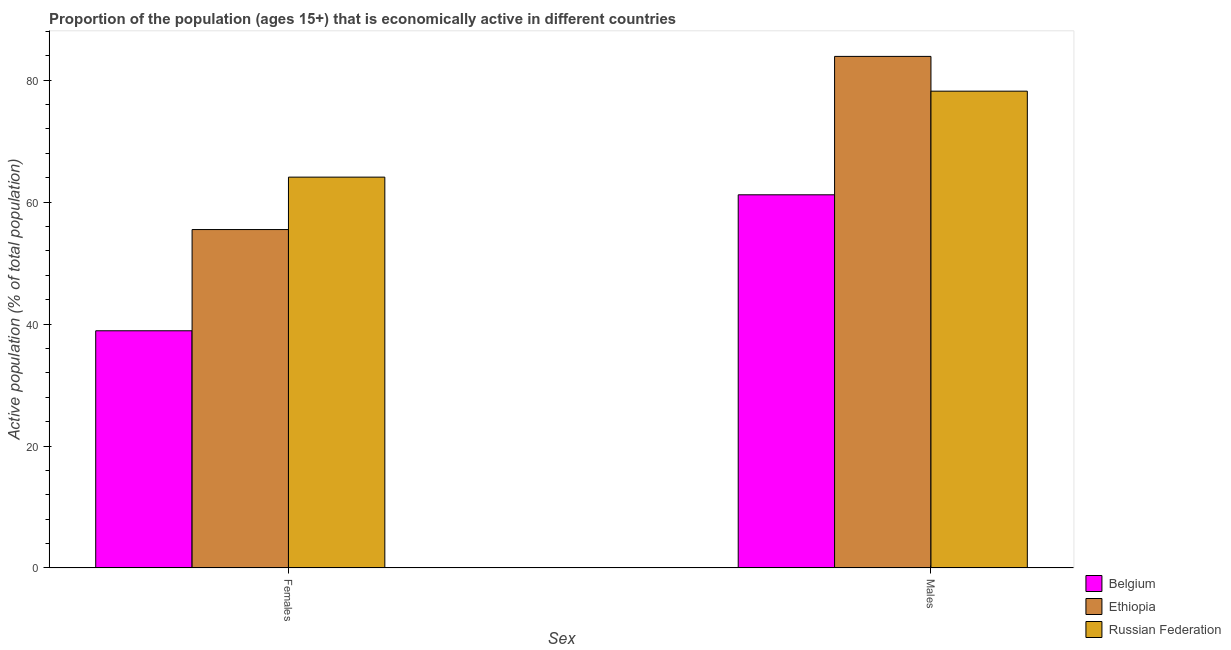How many different coloured bars are there?
Keep it short and to the point. 3. How many groups of bars are there?
Keep it short and to the point. 2. Are the number of bars on each tick of the X-axis equal?
Offer a terse response. Yes. How many bars are there on the 2nd tick from the left?
Offer a terse response. 3. How many bars are there on the 1st tick from the right?
Give a very brief answer. 3. What is the label of the 2nd group of bars from the left?
Keep it short and to the point. Males. What is the percentage of economically active female population in Ethiopia?
Your response must be concise. 55.5. Across all countries, what is the maximum percentage of economically active male population?
Offer a very short reply. 83.9. Across all countries, what is the minimum percentage of economically active female population?
Offer a terse response. 38.9. In which country was the percentage of economically active male population maximum?
Your answer should be compact. Ethiopia. In which country was the percentage of economically active male population minimum?
Offer a terse response. Belgium. What is the total percentage of economically active female population in the graph?
Provide a short and direct response. 158.5. What is the difference between the percentage of economically active female population in Russian Federation and that in Ethiopia?
Offer a terse response. 8.6. What is the difference between the percentage of economically active male population in Belgium and the percentage of economically active female population in Ethiopia?
Ensure brevity in your answer.  5.7. What is the average percentage of economically active female population per country?
Provide a short and direct response. 52.83. What is the difference between the percentage of economically active male population and percentage of economically active female population in Belgium?
Offer a very short reply. 22.3. What is the ratio of the percentage of economically active female population in Belgium to that in Russian Federation?
Offer a very short reply. 0.61. What does the 2nd bar from the left in Females represents?
Make the answer very short. Ethiopia. What does the 2nd bar from the right in Females represents?
Provide a succinct answer. Ethiopia. How many bars are there?
Your response must be concise. 6. Are the values on the major ticks of Y-axis written in scientific E-notation?
Give a very brief answer. No. Does the graph contain any zero values?
Your answer should be very brief. No. Where does the legend appear in the graph?
Provide a succinct answer. Bottom right. How are the legend labels stacked?
Offer a very short reply. Vertical. What is the title of the graph?
Offer a terse response. Proportion of the population (ages 15+) that is economically active in different countries. What is the label or title of the X-axis?
Provide a short and direct response. Sex. What is the label or title of the Y-axis?
Keep it short and to the point. Active population (% of total population). What is the Active population (% of total population) in Belgium in Females?
Your response must be concise. 38.9. What is the Active population (% of total population) of Ethiopia in Females?
Ensure brevity in your answer.  55.5. What is the Active population (% of total population) of Russian Federation in Females?
Your answer should be very brief. 64.1. What is the Active population (% of total population) in Belgium in Males?
Provide a short and direct response. 61.2. What is the Active population (% of total population) in Ethiopia in Males?
Ensure brevity in your answer.  83.9. What is the Active population (% of total population) of Russian Federation in Males?
Your response must be concise. 78.2. Across all Sex, what is the maximum Active population (% of total population) in Belgium?
Your response must be concise. 61.2. Across all Sex, what is the maximum Active population (% of total population) in Ethiopia?
Your response must be concise. 83.9. Across all Sex, what is the maximum Active population (% of total population) in Russian Federation?
Your answer should be very brief. 78.2. Across all Sex, what is the minimum Active population (% of total population) of Belgium?
Keep it short and to the point. 38.9. Across all Sex, what is the minimum Active population (% of total population) in Ethiopia?
Provide a short and direct response. 55.5. Across all Sex, what is the minimum Active population (% of total population) in Russian Federation?
Keep it short and to the point. 64.1. What is the total Active population (% of total population) in Belgium in the graph?
Offer a terse response. 100.1. What is the total Active population (% of total population) of Ethiopia in the graph?
Ensure brevity in your answer.  139.4. What is the total Active population (% of total population) in Russian Federation in the graph?
Your answer should be compact. 142.3. What is the difference between the Active population (% of total population) in Belgium in Females and that in Males?
Offer a terse response. -22.3. What is the difference between the Active population (% of total population) in Ethiopia in Females and that in Males?
Your answer should be very brief. -28.4. What is the difference between the Active population (% of total population) of Russian Federation in Females and that in Males?
Your answer should be very brief. -14.1. What is the difference between the Active population (% of total population) in Belgium in Females and the Active population (% of total population) in Ethiopia in Males?
Provide a short and direct response. -45. What is the difference between the Active population (% of total population) in Belgium in Females and the Active population (% of total population) in Russian Federation in Males?
Offer a very short reply. -39.3. What is the difference between the Active population (% of total population) in Ethiopia in Females and the Active population (% of total population) in Russian Federation in Males?
Your answer should be compact. -22.7. What is the average Active population (% of total population) in Belgium per Sex?
Offer a very short reply. 50.05. What is the average Active population (% of total population) of Ethiopia per Sex?
Provide a short and direct response. 69.7. What is the average Active population (% of total population) in Russian Federation per Sex?
Offer a terse response. 71.15. What is the difference between the Active population (% of total population) in Belgium and Active population (% of total population) in Ethiopia in Females?
Give a very brief answer. -16.6. What is the difference between the Active population (% of total population) of Belgium and Active population (% of total population) of Russian Federation in Females?
Offer a very short reply. -25.2. What is the difference between the Active population (% of total population) of Ethiopia and Active population (% of total population) of Russian Federation in Females?
Offer a terse response. -8.6. What is the difference between the Active population (% of total population) of Belgium and Active population (% of total population) of Ethiopia in Males?
Give a very brief answer. -22.7. What is the ratio of the Active population (% of total population) in Belgium in Females to that in Males?
Your response must be concise. 0.64. What is the ratio of the Active population (% of total population) of Ethiopia in Females to that in Males?
Your answer should be compact. 0.66. What is the ratio of the Active population (% of total population) of Russian Federation in Females to that in Males?
Offer a terse response. 0.82. What is the difference between the highest and the second highest Active population (% of total population) in Belgium?
Ensure brevity in your answer.  22.3. What is the difference between the highest and the second highest Active population (% of total population) of Ethiopia?
Keep it short and to the point. 28.4. What is the difference between the highest and the lowest Active population (% of total population) in Belgium?
Your answer should be very brief. 22.3. What is the difference between the highest and the lowest Active population (% of total population) of Ethiopia?
Ensure brevity in your answer.  28.4. 